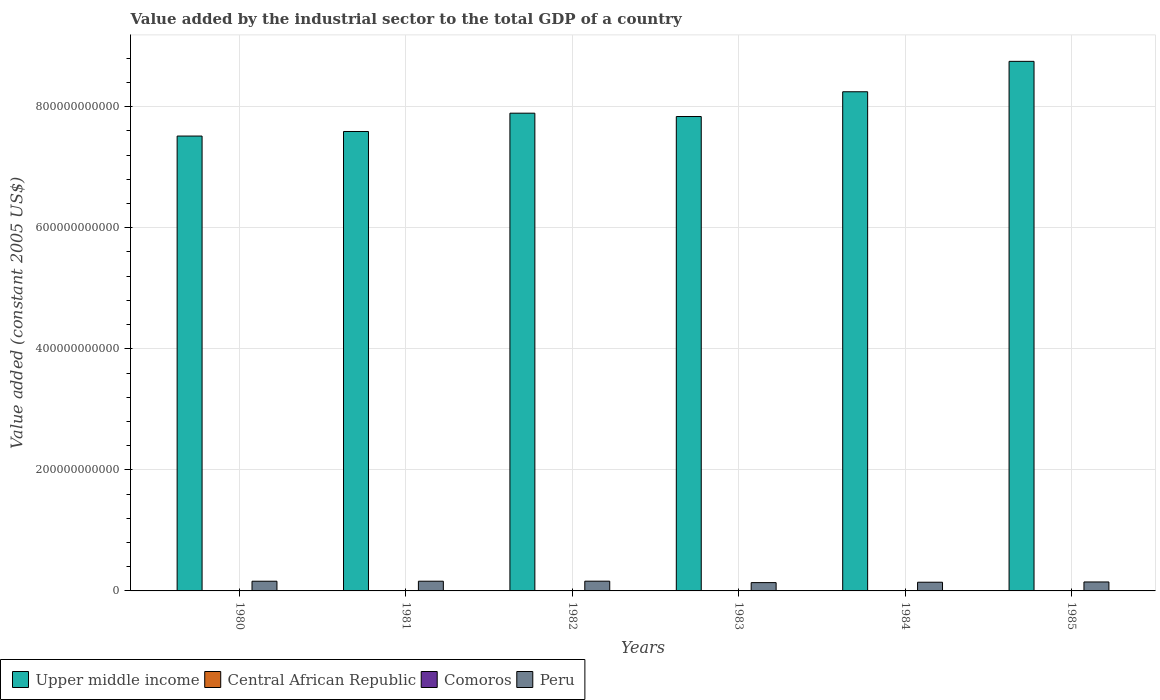How many groups of bars are there?
Your answer should be compact. 6. How many bars are there on the 4th tick from the right?
Your response must be concise. 4. What is the label of the 5th group of bars from the left?
Offer a terse response. 1984. What is the value added by the industrial sector in Peru in 1980?
Offer a terse response. 1.60e+1. Across all years, what is the maximum value added by the industrial sector in Peru?
Offer a very short reply. 1.61e+1. Across all years, what is the minimum value added by the industrial sector in Comoros?
Keep it short and to the point. 3.00e+07. In which year was the value added by the industrial sector in Peru minimum?
Provide a short and direct response. 1983. What is the total value added by the industrial sector in Peru in the graph?
Your answer should be compact. 9.11e+1. What is the difference between the value added by the industrial sector in Comoros in 1980 and that in 1982?
Give a very brief answer. -4.19e+06. What is the difference between the value added by the industrial sector in Comoros in 1982 and the value added by the industrial sector in Upper middle income in 1985?
Offer a very short reply. -8.75e+11. What is the average value added by the industrial sector in Comoros per year?
Your answer should be compact. 3.35e+07. In the year 1982, what is the difference between the value added by the industrial sector in Peru and value added by the industrial sector in Central African Republic?
Your response must be concise. 1.60e+1. In how many years, is the value added by the industrial sector in Central African Republic greater than 320000000000 US$?
Your answer should be compact. 0. What is the ratio of the value added by the industrial sector in Central African Republic in 1981 to that in 1983?
Offer a terse response. 0.92. Is the difference between the value added by the industrial sector in Peru in 1982 and 1985 greater than the difference between the value added by the industrial sector in Central African Republic in 1982 and 1985?
Your answer should be very brief. Yes. What is the difference between the highest and the second highest value added by the industrial sector in Peru?
Your answer should be very brief. 6.86e+07. What is the difference between the highest and the lowest value added by the industrial sector in Upper middle income?
Make the answer very short. 1.23e+11. What does the 1st bar from the left in 1984 represents?
Provide a succinct answer. Upper middle income. Is it the case that in every year, the sum of the value added by the industrial sector in Peru and value added by the industrial sector in Central African Republic is greater than the value added by the industrial sector in Upper middle income?
Give a very brief answer. No. How many bars are there?
Your answer should be compact. 24. How many years are there in the graph?
Ensure brevity in your answer.  6. What is the difference between two consecutive major ticks on the Y-axis?
Your answer should be very brief. 2.00e+11. Does the graph contain grids?
Your response must be concise. Yes. Where does the legend appear in the graph?
Make the answer very short. Bottom left. What is the title of the graph?
Give a very brief answer. Value added by the industrial sector to the total GDP of a country. Does "Italy" appear as one of the legend labels in the graph?
Give a very brief answer. No. What is the label or title of the Y-axis?
Offer a terse response. Value added (constant 2005 US$). What is the Value added (constant 2005 US$) of Upper middle income in 1980?
Offer a very short reply. 7.51e+11. What is the Value added (constant 2005 US$) of Central African Republic in 1980?
Offer a terse response. 1.59e+08. What is the Value added (constant 2005 US$) in Comoros in 1980?
Provide a succinct answer. 3.00e+07. What is the Value added (constant 2005 US$) in Peru in 1980?
Offer a terse response. 1.60e+1. What is the Value added (constant 2005 US$) of Upper middle income in 1981?
Offer a very short reply. 7.59e+11. What is the Value added (constant 2005 US$) in Central African Republic in 1981?
Give a very brief answer. 1.46e+08. What is the Value added (constant 2005 US$) in Comoros in 1981?
Your answer should be very brief. 3.03e+07. What is the Value added (constant 2005 US$) in Peru in 1981?
Keep it short and to the point. 1.60e+1. What is the Value added (constant 2005 US$) of Upper middle income in 1982?
Make the answer very short. 7.89e+11. What is the Value added (constant 2005 US$) of Central African Republic in 1982?
Keep it short and to the point. 1.46e+08. What is the Value added (constant 2005 US$) in Comoros in 1982?
Provide a short and direct response. 3.42e+07. What is the Value added (constant 2005 US$) of Peru in 1982?
Your answer should be compact. 1.61e+1. What is the Value added (constant 2005 US$) in Upper middle income in 1983?
Your response must be concise. 7.84e+11. What is the Value added (constant 2005 US$) in Central African Republic in 1983?
Keep it short and to the point. 1.59e+08. What is the Value added (constant 2005 US$) of Comoros in 1983?
Make the answer very short. 3.44e+07. What is the Value added (constant 2005 US$) of Peru in 1983?
Provide a succinct answer. 1.37e+1. What is the Value added (constant 2005 US$) in Upper middle income in 1984?
Provide a short and direct response. 8.25e+11. What is the Value added (constant 2005 US$) of Central African Republic in 1984?
Your response must be concise. 1.63e+08. What is the Value added (constant 2005 US$) in Comoros in 1984?
Your answer should be compact. 3.69e+07. What is the Value added (constant 2005 US$) in Peru in 1984?
Offer a very short reply. 1.44e+1. What is the Value added (constant 2005 US$) in Upper middle income in 1985?
Your response must be concise. 8.75e+11. What is the Value added (constant 2005 US$) of Central African Republic in 1985?
Ensure brevity in your answer.  1.69e+08. What is the Value added (constant 2005 US$) of Comoros in 1985?
Your answer should be compact. 3.53e+07. What is the Value added (constant 2005 US$) of Peru in 1985?
Offer a terse response. 1.48e+1. Across all years, what is the maximum Value added (constant 2005 US$) in Upper middle income?
Make the answer very short. 8.75e+11. Across all years, what is the maximum Value added (constant 2005 US$) of Central African Republic?
Ensure brevity in your answer.  1.69e+08. Across all years, what is the maximum Value added (constant 2005 US$) of Comoros?
Offer a terse response. 3.69e+07. Across all years, what is the maximum Value added (constant 2005 US$) in Peru?
Your answer should be very brief. 1.61e+1. Across all years, what is the minimum Value added (constant 2005 US$) of Upper middle income?
Your response must be concise. 7.51e+11. Across all years, what is the minimum Value added (constant 2005 US$) of Central African Republic?
Give a very brief answer. 1.46e+08. Across all years, what is the minimum Value added (constant 2005 US$) in Comoros?
Provide a succinct answer. 3.00e+07. Across all years, what is the minimum Value added (constant 2005 US$) in Peru?
Keep it short and to the point. 1.37e+1. What is the total Value added (constant 2005 US$) of Upper middle income in the graph?
Provide a short and direct response. 4.78e+12. What is the total Value added (constant 2005 US$) in Central African Republic in the graph?
Give a very brief answer. 9.42e+08. What is the total Value added (constant 2005 US$) of Comoros in the graph?
Provide a succinct answer. 2.01e+08. What is the total Value added (constant 2005 US$) of Peru in the graph?
Ensure brevity in your answer.  9.11e+1. What is the difference between the Value added (constant 2005 US$) in Upper middle income in 1980 and that in 1981?
Give a very brief answer. -7.55e+09. What is the difference between the Value added (constant 2005 US$) in Central African Republic in 1980 and that in 1981?
Your answer should be very brief. 1.27e+07. What is the difference between the Value added (constant 2005 US$) in Comoros in 1980 and that in 1981?
Make the answer very short. -2.66e+05. What is the difference between the Value added (constant 2005 US$) in Peru in 1980 and that in 1981?
Keep it short and to the point. -1.73e+07. What is the difference between the Value added (constant 2005 US$) in Upper middle income in 1980 and that in 1982?
Your answer should be very brief. -3.78e+1. What is the difference between the Value added (constant 2005 US$) in Central African Republic in 1980 and that in 1982?
Your answer should be compact. 1.34e+07. What is the difference between the Value added (constant 2005 US$) in Comoros in 1980 and that in 1982?
Offer a terse response. -4.19e+06. What is the difference between the Value added (constant 2005 US$) of Peru in 1980 and that in 1982?
Provide a short and direct response. -8.59e+07. What is the difference between the Value added (constant 2005 US$) of Upper middle income in 1980 and that in 1983?
Your response must be concise. -3.23e+1. What is the difference between the Value added (constant 2005 US$) of Comoros in 1980 and that in 1983?
Offer a very short reply. -4.40e+06. What is the difference between the Value added (constant 2005 US$) of Peru in 1980 and that in 1983?
Provide a succinct answer. 2.28e+09. What is the difference between the Value added (constant 2005 US$) of Upper middle income in 1980 and that in 1984?
Your answer should be very brief. -7.32e+1. What is the difference between the Value added (constant 2005 US$) in Central African Republic in 1980 and that in 1984?
Ensure brevity in your answer.  -4.45e+06. What is the difference between the Value added (constant 2005 US$) of Comoros in 1980 and that in 1984?
Give a very brief answer. -6.81e+06. What is the difference between the Value added (constant 2005 US$) of Peru in 1980 and that in 1984?
Your response must be concise. 1.64e+09. What is the difference between the Value added (constant 2005 US$) of Upper middle income in 1980 and that in 1985?
Offer a terse response. -1.23e+11. What is the difference between the Value added (constant 2005 US$) of Central African Republic in 1980 and that in 1985?
Ensure brevity in your answer.  -1.02e+07. What is the difference between the Value added (constant 2005 US$) of Comoros in 1980 and that in 1985?
Your response must be concise. -5.29e+06. What is the difference between the Value added (constant 2005 US$) in Peru in 1980 and that in 1985?
Make the answer very short. 1.20e+09. What is the difference between the Value added (constant 2005 US$) in Upper middle income in 1981 and that in 1982?
Offer a very short reply. -3.02e+1. What is the difference between the Value added (constant 2005 US$) in Central African Republic in 1981 and that in 1982?
Give a very brief answer. 6.36e+05. What is the difference between the Value added (constant 2005 US$) of Comoros in 1981 and that in 1982?
Give a very brief answer. -3.92e+06. What is the difference between the Value added (constant 2005 US$) in Peru in 1981 and that in 1982?
Keep it short and to the point. -6.86e+07. What is the difference between the Value added (constant 2005 US$) of Upper middle income in 1981 and that in 1983?
Keep it short and to the point. -2.47e+1. What is the difference between the Value added (constant 2005 US$) in Central African Republic in 1981 and that in 1983?
Keep it short and to the point. -1.27e+07. What is the difference between the Value added (constant 2005 US$) of Comoros in 1981 and that in 1983?
Offer a very short reply. -4.14e+06. What is the difference between the Value added (constant 2005 US$) of Peru in 1981 and that in 1983?
Keep it short and to the point. 2.30e+09. What is the difference between the Value added (constant 2005 US$) in Upper middle income in 1981 and that in 1984?
Ensure brevity in your answer.  -6.56e+1. What is the difference between the Value added (constant 2005 US$) in Central African Republic in 1981 and that in 1984?
Your response must be concise. -1.72e+07. What is the difference between the Value added (constant 2005 US$) of Comoros in 1981 and that in 1984?
Make the answer very short. -6.54e+06. What is the difference between the Value added (constant 2005 US$) of Peru in 1981 and that in 1984?
Your response must be concise. 1.66e+09. What is the difference between the Value added (constant 2005 US$) of Upper middle income in 1981 and that in 1985?
Ensure brevity in your answer.  -1.16e+11. What is the difference between the Value added (constant 2005 US$) of Central African Republic in 1981 and that in 1985?
Offer a very short reply. -2.29e+07. What is the difference between the Value added (constant 2005 US$) of Comoros in 1981 and that in 1985?
Your answer should be compact. -5.03e+06. What is the difference between the Value added (constant 2005 US$) of Peru in 1981 and that in 1985?
Give a very brief answer. 1.22e+09. What is the difference between the Value added (constant 2005 US$) of Upper middle income in 1982 and that in 1983?
Your answer should be compact. 5.53e+09. What is the difference between the Value added (constant 2005 US$) in Central African Republic in 1982 and that in 1983?
Keep it short and to the point. -1.34e+07. What is the difference between the Value added (constant 2005 US$) of Comoros in 1982 and that in 1983?
Keep it short and to the point. -2.15e+05. What is the difference between the Value added (constant 2005 US$) of Peru in 1982 and that in 1983?
Offer a terse response. 2.37e+09. What is the difference between the Value added (constant 2005 US$) of Upper middle income in 1982 and that in 1984?
Offer a very short reply. -3.54e+1. What is the difference between the Value added (constant 2005 US$) in Central African Republic in 1982 and that in 1984?
Provide a succinct answer. -1.78e+07. What is the difference between the Value added (constant 2005 US$) in Comoros in 1982 and that in 1984?
Ensure brevity in your answer.  -2.62e+06. What is the difference between the Value added (constant 2005 US$) of Peru in 1982 and that in 1984?
Provide a short and direct response. 1.73e+09. What is the difference between the Value added (constant 2005 US$) in Upper middle income in 1982 and that in 1985?
Offer a terse response. -8.56e+1. What is the difference between the Value added (constant 2005 US$) of Central African Republic in 1982 and that in 1985?
Provide a succinct answer. -2.35e+07. What is the difference between the Value added (constant 2005 US$) of Comoros in 1982 and that in 1985?
Offer a very short reply. -1.10e+06. What is the difference between the Value added (constant 2005 US$) of Peru in 1982 and that in 1985?
Your response must be concise. 1.28e+09. What is the difference between the Value added (constant 2005 US$) of Upper middle income in 1983 and that in 1984?
Your answer should be compact. -4.09e+1. What is the difference between the Value added (constant 2005 US$) of Central African Republic in 1983 and that in 1984?
Your answer should be very brief. -4.45e+06. What is the difference between the Value added (constant 2005 US$) of Comoros in 1983 and that in 1984?
Your answer should be very brief. -2.40e+06. What is the difference between the Value added (constant 2005 US$) of Peru in 1983 and that in 1984?
Give a very brief answer. -6.42e+08. What is the difference between the Value added (constant 2005 US$) of Upper middle income in 1983 and that in 1985?
Make the answer very short. -9.11e+1. What is the difference between the Value added (constant 2005 US$) of Central African Republic in 1983 and that in 1985?
Keep it short and to the point. -1.02e+07. What is the difference between the Value added (constant 2005 US$) in Comoros in 1983 and that in 1985?
Make the answer very short. -8.90e+05. What is the difference between the Value added (constant 2005 US$) of Peru in 1983 and that in 1985?
Your answer should be compact. -1.09e+09. What is the difference between the Value added (constant 2005 US$) in Upper middle income in 1984 and that in 1985?
Offer a terse response. -5.02e+1. What is the difference between the Value added (constant 2005 US$) in Central African Republic in 1984 and that in 1985?
Your answer should be compact. -5.72e+06. What is the difference between the Value added (constant 2005 US$) in Comoros in 1984 and that in 1985?
Your response must be concise. 1.51e+06. What is the difference between the Value added (constant 2005 US$) of Peru in 1984 and that in 1985?
Keep it short and to the point. -4.45e+08. What is the difference between the Value added (constant 2005 US$) of Upper middle income in 1980 and the Value added (constant 2005 US$) of Central African Republic in 1981?
Your answer should be compact. 7.51e+11. What is the difference between the Value added (constant 2005 US$) of Upper middle income in 1980 and the Value added (constant 2005 US$) of Comoros in 1981?
Provide a short and direct response. 7.51e+11. What is the difference between the Value added (constant 2005 US$) in Upper middle income in 1980 and the Value added (constant 2005 US$) in Peru in 1981?
Your answer should be compact. 7.35e+11. What is the difference between the Value added (constant 2005 US$) of Central African Republic in 1980 and the Value added (constant 2005 US$) of Comoros in 1981?
Your answer should be very brief. 1.29e+08. What is the difference between the Value added (constant 2005 US$) in Central African Republic in 1980 and the Value added (constant 2005 US$) in Peru in 1981?
Offer a terse response. -1.59e+1. What is the difference between the Value added (constant 2005 US$) of Comoros in 1980 and the Value added (constant 2005 US$) of Peru in 1981?
Provide a succinct answer. -1.60e+1. What is the difference between the Value added (constant 2005 US$) in Upper middle income in 1980 and the Value added (constant 2005 US$) in Central African Republic in 1982?
Offer a terse response. 7.51e+11. What is the difference between the Value added (constant 2005 US$) of Upper middle income in 1980 and the Value added (constant 2005 US$) of Comoros in 1982?
Provide a short and direct response. 7.51e+11. What is the difference between the Value added (constant 2005 US$) of Upper middle income in 1980 and the Value added (constant 2005 US$) of Peru in 1982?
Offer a terse response. 7.35e+11. What is the difference between the Value added (constant 2005 US$) of Central African Republic in 1980 and the Value added (constant 2005 US$) of Comoros in 1982?
Make the answer very short. 1.25e+08. What is the difference between the Value added (constant 2005 US$) of Central African Republic in 1980 and the Value added (constant 2005 US$) of Peru in 1982?
Your answer should be compact. -1.59e+1. What is the difference between the Value added (constant 2005 US$) in Comoros in 1980 and the Value added (constant 2005 US$) in Peru in 1982?
Ensure brevity in your answer.  -1.61e+1. What is the difference between the Value added (constant 2005 US$) of Upper middle income in 1980 and the Value added (constant 2005 US$) of Central African Republic in 1983?
Provide a succinct answer. 7.51e+11. What is the difference between the Value added (constant 2005 US$) of Upper middle income in 1980 and the Value added (constant 2005 US$) of Comoros in 1983?
Offer a terse response. 7.51e+11. What is the difference between the Value added (constant 2005 US$) in Upper middle income in 1980 and the Value added (constant 2005 US$) in Peru in 1983?
Keep it short and to the point. 7.38e+11. What is the difference between the Value added (constant 2005 US$) of Central African Republic in 1980 and the Value added (constant 2005 US$) of Comoros in 1983?
Provide a short and direct response. 1.24e+08. What is the difference between the Value added (constant 2005 US$) of Central African Republic in 1980 and the Value added (constant 2005 US$) of Peru in 1983?
Give a very brief answer. -1.36e+1. What is the difference between the Value added (constant 2005 US$) in Comoros in 1980 and the Value added (constant 2005 US$) in Peru in 1983?
Your response must be concise. -1.37e+1. What is the difference between the Value added (constant 2005 US$) in Upper middle income in 1980 and the Value added (constant 2005 US$) in Central African Republic in 1984?
Keep it short and to the point. 7.51e+11. What is the difference between the Value added (constant 2005 US$) in Upper middle income in 1980 and the Value added (constant 2005 US$) in Comoros in 1984?
Offer a very short reply. 7.51e+11. What is the difference between the Value added (constant 2005 US$) in Upper middle income in 1980 and the Value added (constant 2005 US$) in Peru in 1984?
Your response must be concise. 7.37e+11. What is the difference between the Value added (constant 2005 US$) of Central African Republic in 1980 and the Value added (constant 2005 US$) of Comoros in 1984?
Offer a very short reply. 1.22e+08. What is the difference between the Value added (constant 2005 US$) in Central African Republic in 1980 and the Value added (constant 2005 US$) in Peru in 1984?
Ensure brevity in your answer.  -1.42e+1. What is the difference between the Value added (constant 2005 US$) of Comoros in 1980 and the Value added (constant 2005 US$) of Peru in 1984?
Your response must be concise. -1.43e+1. What is the difference between the Value added (constant 2005 US$) of Upper middle income in 1980 and the Value added (constant 2005 US$) of Central African Republic in 1985?
Give a very brief answer. 7.51e+11. What is the difference between the Value added (constant 2005 US$) in Upper middle income in 1980 and the Value added (constant 2005 US$) in Comoros in 1985?
Give a very brief answer. 7.51e+11. What is the difference between the Value added (constant 2005 US$) in Upper middle income in 1980 and the Value added (constant 2005 US$) in Peru in 1985?
Your response must be concise. 7.37e+11. What is the difference between the Value added (constant 2005 US$) of Central African Republic in 1980 and the Value added (constant 2005 US$) of Comoros in 1985?
Make the answer very short. 1.24e+08. What is the difference between the Value added (constant 2005 US$) of Central African Republic in 1980 and the Value added (constant 2005 US$) of Peru in 1985?
Offer a terse response. -1.47e+1. What is the difference between the Value added (constant 2005 US$) in Comoros in 1980 and the Value added (constant 2005 US$) in Peru in 1985?
Offer a terse response. -1.48e+1. What is the difference between the Value added (constant 2005 US$) in Upper middle income in 1981 and the Value added (constant 2005 US$) in Central African Republic in 1982?
Ensure brevity in your answer.  7.59e+11. What is the difference between the Value added (constant 2005 US$) in Upper middle income in 1981 and the Value added (constant 2005 US$) in Comoros in 1982?
Your answer should be very brief. 7.59e+11. What is the difference between the Value added (constant 2005 US$) of Upper middle income in 1981 and the Value added (constant 2005 US$) of Peru in 1982?
Your answer should be very brief. 7.43e+11. What is the difference between the Value added (constant 2005 US$) of Central African Republic in 1981 and the Value added (constant 2005 US$) of Comoros in 1982?
Offer a terse response. 1.12e+08. What is the difference between the Value added (constant 2005 US$) of Central African Republic in 1981 and the Value added (constant 2005 US$) of Peru in 1982?
Give a very brief answer. -1.60e+1. What is the difference between the Value added (constant 2005 US$) of Comoros in 1981 and the Value added (constant 2005 US$) of Peru in 1982?
Make the answer very short. -1.61e+1. What is the difference between the Value added (constant 2005 US$) in Upper middle income in 1981 and the Value added (constant 2005 US$) in Central African Republic in 1983?
Provide a short and direct response. 7.59e+11. What is the difference between the Value added (constant 2005 US$) of Upper middle income in 1981 and the Value added (constant 2005 US$) of Comoros in 1983?
Provide a succinct answer. 7.59e+11. What is the difference between the Value added (constant 2005 US$) of Upper middle income in 1981 and the Value added (constant 2005 US$) of Peru in 1983?
Make the answer very short. 7.45e+11. What is the difference between the Value added (constant 2005 US$) of Central African Republic in 1981 and the Value added (constant 2005 US$) of Comoros in 1983?
Keep it short and to the point. 1.12e+08. What is the difference between the Value added (constant 2005 US$) of Central African Republic in 1981 and the Value added (constant 2005 US$) of Peru in 1983?
Give a very brief answer. -1.36e+1. What is the difference between the Value added (constant 2005 US$) in Comoros in 1981 and the Value added (constant 2005 US$) in Peru in 1983?
Offer a terse response. -1.37e+1. What is the difference between the Value added (constant 2005 US$) in Upper middle income in 1981 and the Value added (constant 2005 US$) in Central African Republic in 1984?
Ensure brevity in your answer.  7.59e+11. What is the difference between the Value added (constant 2005 US$) in Upper middle income in 1981 and the Value added (constant 2005 US$) in Comoros in 1984?
Offer a very short reply. 7.59e+11. What is the difference between the Value added (constant 2005 US$) of Upper middle income in 1981 and the Value added (constant 2005 US$) of Peru in 1984?
Keep it short and to the point. 7.45e+11. What is the difference between the Value added (constant 2005 US$) of Central African Republic in 1981 and the Value added (constant 2005 US$) of Comoros in 1984?
Offer a very short reply. 1.09e+08. What is the difference between the Value added (constant 2005 US$) in Central African Republic in 1981 and the Value added (constant 2005 US$) in Peru in 1984?
Keep it short and to the point. -1.42e+1. What is the difference between the Value added (constant 2005 US$) of Comoros in 1981 and the Value added (constant 2005 US$) of Peru in 1984?
Your response must be concise. -1.43e+1. What is the difference between the Value added (constant 2005 US$) in Upper middle income in 1981 and the Value added (constant 2005 US$) in Central African Republic in 1985?
Give a very brief answer. 7.59e+11. What is the difference between the Value added (constant 2005 US$) of Upper middle income in 1981 and the Value added (constant 2005 US$) of Comoros in 1985?
Provide a succinct answer. 7.59e+11. What is the difference between the Value added (constant 2005 US$) of Upper middle income in 1981 and the Value added (constant 2005 US$) of Peru in 1985?
Make the answer very short. 7.44e+11. What is the difference between the Value added (constant 2005 US$) in Central African Republic in 1981 and the Value added (constant 2005 US$) in Comoros in 1985?
Your answer should be very brief. 1.11e+08. What is the difference between the Value added (constant 2005 US$) of Central African Republic in 1981 and the Value added (constant 2005 US$) of Peru in 1985?
Offer a terse response. -1.47e+1. What is the difference between the Value added (constant 2005 US$) of Comoros in 1981 and the Value added (constant 2005 US$) of Peru in 1985?
Keep it short and to the point. -1.48e+1. What is the difference between the Value added (constant 2005 US$) in Upper middle income in 1982 and the Value added (constant 2005 US$) in Central African Republic in 1983?
Make the answer very short. 7.89e+11. What is the difference between the Value added (constant 2005 US$) of Upper middle income in 1982 and the Value added (constant 2005 US$) of Comoros in 1983?
Make the answer very short. 7.89e+11. What is the difference between the Value added (constant 2005 US$) in Upper middle income in 1982 and the Value added (constant 2005 US$) in Peru in 1983?
Give a very brief answer. 7.76e+11. What is the difference between the Value added (constant 2005 US$) of Central African Republic in 1982 and the Value added (constant 2005 US$) of Comoros in 1983?
Your answer should be compact. 1.11e+08. What is the difference between the Value added (constant 2005 US$) of Central African Republic in 1982 and the Value added (constant 2005 US$) of Peru in 1983?
Provide a short and direct response. -1.36e+1. What is the difference between the Value added (constant 2005 US$) in Comoros in 1982 and the Value added (constant 2005 US$) in Peru in 1983?
Give a very brief answer. -1.37e+1. What is the difference between the Value added (constant 2005 US$) of Upper middle income in 1982 and the Value added (constant 2005 US$) of Central African Republic in 1984?
Your answer should be compact. 7.89e+11. What is the difference between the Value added (constant 2005 US$) in Upper middle income in 1982 and the Value added (constant 2005 US$) in Comoros in 1984?
Keep it short and to the point. 7.89e+11. What is the difference between the Value added (constant 2005 US$) of Upper middle income in 1982 and the Value added (constant 2005 US$) of Peru in 1984?
Make the answer very short. 7.75e+11. What is the difference between the Value added (constant 2005 US$) in Central African Republic in 1982 and the Value added (constant 2005 US$) in Comoros in 1984?
Make the answer very short. 1.09e+08. What is the difference between the Value added (constant 2005 US$) in Central African Republic in 1982 and the Value added (constant 2005 US$) in Peru in 1984?
Ensure brevity in your answer.  -1.42e+1. What is the difference between the Value added (constant 2005 US$) of Comoros in 1982 and the Value added (constant 2005 US$) of Peru in 1984?
Ensure brevity in your answer.  -1.43e+1. What is the difference between the Value added (constant 2005 US$) of Upper middle income in 1982 and the Value added (constant 2005 US$) of Central African Republic in 1985?
Provide a succinct answer. 7.89e+11. What is the difference between the Value added (constant 2005 US$) of Upper middle income in 1982 and the Value added (constant 2005 US$) of Comoros in 1985?
Give a very brief answer. 7.89e+11. What is the difference between the Value added (constant 2005 US$) in Upper middle income in 1982 and the Value added (constant 2005 US$) in Peru in 1985?
Provide a succinct answer. 7.74e+11. What is the difference between the Value added (constant 2005 US$) in Central African Republic in 1982 and the Value added (constant 2005 US$) in Comoros in 1985?
Ensure brevity in your answer.  1.10e+08. What is the difference between the Value added (constant 2005 US$) of Central African Republic in 1982 and the Value added (constant 2005 US$) of Peru in 1985?
Offer a very short reply. -1.47e+1. What is the difference between the Value added (constant 2005 US$) in Comoros in 1982 and the Value added (constant 2005 US$) in Peru in 1985?
Make the answer very short. -1.48e+1. What is the difference between the Value added (constant 2005 US$) in Upper middle income in 1983 and the Value added (constant 2005 US$) in Central African Republic in 1984?
Provide a short and direct response. 7.84e+11. What is the difference between the Value added (constant 2005 US$) of Upper middle income in 1983 and the Value added (constant 2005 US$) of Comoros in 1984?
Your response must be concise. 7.84e+11. What is the difference between the Value added (constant 2005 US$) in Upper middle income in 1983 and the Value added (constant 2005 US$) in Peru in 1984?
Offer a very short reply. 7.69e+11. What is the difference between the Value added (constant 2005 US$) of Central African Republic in 1983 and the Value added (constant 2005 US$) of Comoros in 1984?
Offer a very short reply. 1.22e+08. What is the difference between the Value added (constant 2005 US$) of Central African Republic in 1983 and the Value added (constant 2005 US$) of Peru in 1984?
Provide a short and direct response. -1.42e+1. What is the difference between the Value added (constant 2005 US$) in Comoros in 1983 and the Value added (constant 2005 US$) in Peru in 1984?
Your answer should be compact. -1.43e+1. What is the difference between the Value added (constant 2005 US$) in Upper middle income in 1983 and the Value added (constant 2005 US$) in Central African Republic in 1985?
Your response must be concise. 7.84e+11. What is the difference between the Value added (constant 2005 US$) in Upper middle income in 1983 and the Value added (constant 2005 US$) in Comoros in 1985?
Keep it short and to the point. 7.84e+11. What is the difference between the Value added (constant 2005 US$) of Upper middle income in 1983 and the Value added (constant 2005 US$) of Peru in 1985?
Your answer should be compact. 7.69e+11. What is the difference between the Value added (constant 2005 US$) in Central African Republic in 1983 and the Value added (constant 2005 US$) in Comoros in 1985?
Keep it short and to the point. 1.24e+08. What is the difference between the Value added (constant 2005 US$) of Central African Republic in 1983 and the Value added (constant 2005 US$) of Peru in 1985?
Your answer should be very brief. -1.47e+1. What is the difference between the Value added (constant 2005 US$) of Comoros in 1983 and the Value added (constant 2005 US$) of Peru in 1985?
Offer a very short reply. -1.48e+1. What is the difference between the Value added (constant 2005 US$) in Upper middle income in 1984 and the Value added (constant 2005 US$) in Central African Republic in 1985?
Offer a very short reply. 8.24e+11. What is the difference between the Value added (constant 2005 US$) of Upper middle income in 1984 and the Value added (constant 2005 US$) of Comoros in 1985?
Provide a succinct answer. 8.25e+11. What is the difference between the Value added (constant 2005 US$) in Upper middle income in 1984 and the Value added (constant 2005 US$) in Peru in 1985?
Offer a very short reply. 8.10e+11. What is the difference between the Value added (constant 2005 US$) in Central African Republic in 1984 and the Value added (constant 2005 US$) in Comoros in 1985?
Give a very brief answer. 1.28e+08. What is the difference between the Value added (constant 2005 US$) of Central African Republic in 1984 and the Value added (constant 2005 US$) of Peru in 1985?
Your answer should be compact. -1.47e+1. What is the difference between the Value added (constant 2005 US$) of Comoros in 1984 and the Value added (constant 2005 US$) of Peru in 1985?
Keep it short and to the point. -1.48e+1. What is the average Value added (constant 2005 US$) of Upper middle income per year?
Your answer should be very brief. 7.97e+11. What is the average Value added (constant 2005 US$) of Central African Republic per year?
Offer a very short reply. 1.57e+08. What is the average Value added (constant 2005 US$) of Comoros per year?
Your answer should be compact. 3.35e+07. What is the average Value added (constant 2005 US$) of Peru per year?
Keep it short and to the point. 1.52e+1. In the year 1980, what is the difference between the Value added (constant 2005 US$) in Upper middle income and Value added (constant 2005 US$) in Central African Republic?
Your response must be concise. 7.51e+11. In the year 1980, what is the difference between the Value added (constant 2005 US$) of Upper middle income and Value added (constant 2005 US$) of Comoros?
Keep it short and to the point. 7.51e+11. In the year 1980, what is the difference between the Value added (constant 2005 US$) in Upper middle income and Value added (constant 2005 US$) in Peru?
Offer a terse response. 7.35e+11. In the year 1980, what is the difference between the Value added (constant 2005 US$) in Central African Republic and Value added (constant 2005 US$) in Comoros?
Give a very brief answer. 1.29e+08. In the year 1980, what is the difference between the Value added (constant 2005 US$) of Central African Republic and Value added (constant 2005 US$) of Peru?
Provide a succinct answer. -1.59e+1. In the year 1980, what is the difference between the Value added (constant 2005 US$) of Comoros and Value added (constant 2005 US$) of Peru?
Ensure brevity in your answer.  -1.60e+1. In the year 1981, what is the difference between the Value added (constant 2005 US$) of Upper middle income and Value added (constant 2005 US$) of Central African Republic?
Give a very brief answer. 7.59e+11. In the year 1981, what is the difference between the Value added (constant 2005 US$) in Upper middle income and Value added (constant 2005 US$) in Comoros?
Keep it short and to the point. 7.59e+11. In the year 1981, what is the difference between the Value added (constant 2005 US$) of Upper middle income and Value added (constant 2005 US$) of Peru?
Your answer should be compact. 7.43e+11. In the year 1981, what is the difference between the Value added (constant 2005 US$) of Central African Republic and Value added (constant 2005 US$) of Comoros?
Your answer should be compact. 1.16e+08. In the year 1981, what is the difference between the Value added (constant 2005 US$) of Central African Republic and Value added (constant 2005 US$) of Peru?
Your response must be concise. -1.59e+1. In the year 1981, what is the difference between the Value added (constant 2005 US$) of Comoros and Value added (constant 2005 US$) of Peru?
Offer a very short reply. -1.60e+1. In the year 1982, what is the difference between the Value added (constant 2005 US$) in Upper middle income and Value added (constant 2005 US$) in Central African Republic?
Your answer should be compact. 7.89e+11. In the year 1982, what is the difference between the Value added (constant 2005 US$) in Upper middle income and Value added (constant 2005 US$) in Comoros?
Provide a short and direct response. 7.89e+11. In the year 1982, what is the difference between the Value added (constant 2005 US$) in Upper middle income and Value added (constant 2005 US$) in Peru?
Provide a succinct answer. 7.73e+11. In the year 1982, what is the difference between the Value added (constant 2005 US$) of Central African Republic and Value added (constant 2005 US$) of Comoros?
Ensure brevity in your answer.  1.11e+08. In the year 1982, what is the difference between the Value added (constant 2005 US$) in Central African Republic and Value added (constant 2005 US$) in Peru?
Ensure brevity in your answer.  -1.60e+1. In the year 1982, what is the difference between the Value added (constant 2005 US$) in Comoros and Value added (constant 2005 US$) in Peru?
Your answer should be very brief. -1.61e+1. In the year 1983, what is the difference between the Value added (constant 2005 US$) in Upper middle income and Value added (constant 2005 US$) in Central African Republic?
Make the answer very short. 7.84e+11. In the year 1983, what is the difference between the Value added (constant 2005 US$) of Upper middle income and Value added (constant 2005 US$) of Comoros?
Provide a succinct answer. 7.84e+11. In the year 1983, what is the difference between the Value added (constant 2005 US$) in Upper middle income and Value added (constant 2005 US$) in Peru?
Your answer should be very brief. 7.70e+11. In the year 1983, what is the difference between the Value added (constant 2005 US$) of Central African Republic and Value added (constant 2005 US$) of Comoros?
Offer a terse response. 1.24e+08. In the year 1983, what is the difference between the Value added (constant 2005 US$) of Central African Republic and Value added (constant 2005 US$) of Peru?
Your answer should be very brief. -1.36e+1. In the year 1983, what is the difference between the Value added (constant 2005 US$) in Comoros and Value added (constant 2005 US$) in Peru?
Offer a very short reply. -1.37e+1. In the year 1984, what is the difference between the Value added (constant 2005 US$) of Upper middle income and Value added (constant 2005 US$) of Central African Republic?
Provide a short and direct response. 8.24e+11. In the year 1984, what is the difference between the Value added (constant 2005 US$) in Upper middle income and Value added (constant 2005 US$) in Comoros?
Provide a short and direct response. 8.25e+11. In the year 1984, what is the difference between the Value added (constant 2005 US$) of Upper middle income and Value added (constant 2005 US$) of Peru?
Give a very brief answer. 8.10e+11. In the year 1984, what is the difference between the Value added (constant 2005 US$) in Central African Republic and Value added (constant 2005 US$) in Comoros?
Your response must be concise. 1.27e+08. In the year 1984, what is the difference between the Value added (constant 2005 US$) in Central African Republic and Value added (constant 2005 US$) in Peru?
Your answer should be compact. -1.42e+1. In the year 1984, what is the difference between the Value added (constant 2005 US$) of Comoros and Value added (constant 2005 US$) of Peru?
Your answer should be very brief. -1.43e+1. In the year 1985, what is the difference between the Value added (constant 2005 US$) of Upper middle income and Value added (constant 2005 US$) of Central African Republic?
Offer a terse response. 8.75e+11. In the year 1985, what is the difference between the Value added (constant 2005 US$) of Upper middle income and Value added (constant 2005 US$) of Comoros?
Give a very brief answer. 8.75e+11. In the year 1985, what is the difference between the Value added (constant 2005 US$) in Upper middle income and Value added (constant 2005 US$) in Peru?
Offer a very short reply. 8.60e+11. In the year 1985, what is the difference between the Value added (constant 2005 US$) in Central African Republic and Value added (constant 2005 US$) in Comoros?
Keep it short and to the point. 1.34e+08. In the year 1985, what is the difference between the Value added (constant 2005 US$) of Central African Republic and Value added (constant 2005 US$) of Peru?
Offer a very short reply. -1.46e+1. In the year 1985, what is the difference between the Value added (constant 2005 US$) of Comoros and Value added (constant 2005 US$) of Peru?
Keep it short and to the point. -1.48e+1. What is the ratio of the Value added (constant 2005 US$) of Upper middle income in 1980 to that in 1981?
Offer a very short reply. 0.99. What is the ratio of the Value added (constant 2005 US$) of Central African Republic in 1980 to that in 1981?
Provide a succinct answer. 1.09. What is the ratio of the Value added (constant 2005 US$) in Comoros in 1980 to that in 1981?
Your answer should be compact. 0.99. What is the ratio of the Value added (constant 2005 US$) in Peru in 1980 to that in 1981?
Make the answer very short. 1. What is the ratio of the Value added (constant 2005 US$) in Upper middle income in 1980 to that in 1982?
Your answer should be compact. 0.95. What is the ratio of the Value added (constant 2005 US$) in Central African Republic in 1980 to that in 1982?
Your response must be concise. 1.09. What is the ratio of the Value added (constant 2005 US$) of Comoros in 1980 to that in 1982?
Provide a succinct answer. 0.88. What is the ratio of the Value added (constant 2005 US$) of Peru in 1980 to that in 1982?
Provide a succinct answer. 0.99. What is the ratio of the Value added (constant 2005 US$) of Upper middle income in 1980 to that in 1983?
Offer a very short reply. 0.96. What is the ratio of the Value added (constant 2005 US$) in Comoros in 1980 to that in 1983?
Your answer should be compact. 0.87. What is the ratio of the Value added (constant 2005 US$) in Peru in 1980 to that in 1983?
Keep it short and to the point. 1.17. What is the ratio of the Value added (constant 2005 US$) in Upper middle income in 1980 to that in 1984?
Your answer should be very brief. 0.91. What is the ratio of the Value added (constant 2005 US$) in Central African Republic in 1980 to that in 1984?
Keep it short and to the point. 0.97. What is the ratio of the Value added (constant 2005 US$) of Comoros in 1980 to that in 1984?
Give a very brief answer. 0.82. What is the ratio of the Value added (constant 2005 US$) in Peru in 1980 to that in 1984?
Your answer should be very brief. 1.11. What is the ratio of the Value added (constant 2005 US$) of Upper middle income in 1980 to that in 1985?
Give a very brief answer. 0.86. What is the ratio of the Value added (constant 2005 US$) of Central African Republic in 1980 to that in 1985?
Make the answer very short. 0.94. What is the ratio of the Value added (constant 2005 US$) of Comoros in 1980 to that in 1985?
Offer a very short reply. 0.85. What is the ratio of the Value added (constant 2005 US$) of Peru in 1980 to that in 1985?
Your answer should be compact. 1.08. What is the ratio of the Value added (constant 2005 US$) in Upper middle income in 1981 to that in 1982?
Your response must be concise. 0.96. What is the ratio of the Value added (constant 2005 US$) in Central African Republic in 1981 to that in 1982?
Keep it short and to the point. 1. What is the ratio of the Value added (constant 2005 US$) in Comoros in 1981 to that in 1982?
Provide a succinct answer. 0.89. What is the ratio of the Value added (constant 2005 US$) of Upper middle income in 1981 to that in 1983?
Ensure brevity in your answer.  0.97. What is the ratio of the Value added (constant 2005 US$) in Comoros in 1981 to that in 1983?
Give a very brief answer. 0.88. What is the ratio of the Value added (constant 2005 US$) in Peru in 1981 to that in 1983?
Your answer should be compact. 1.17. What is the ratio of the Value added (constant 2005 US$) of Upper middle income in 1981 to that in 1984?
Your response must be concise. 0.92. What is the ratio of the Value added (constant 2005 US$) in Central African Republic in 1981 to that in 1984?
Your answer should be compact. 0.89. What is the ratio of the Value added (constant 2005 US$) of Comoros in 1981 to that in 1984?
Offer a very short reply. 0.82. What is the ratio of the Value added (constant 2005 US$) of Peru in 1981 to that in 1984?
Your response must be concise. 1.12. What is the ratio of the Value added (constant 2005 US$) in Upper middle income in 1981 to that in 1985?
Provide a short and direct response. 0.87. What is the ratio of the Value added (constant 2005 US$) of Central African Republic in 1981 to that in 1985?
Offer a very short reply. 0.86. What is the ratio of the Value added (constant 2005 US$) of Comoros in 1981 to that in 1985?
Offer a terse response. 0.86. What is the ratio of the Value added (constant 2005 US$) of Peru in 1981 to that in 1985?
Offer a very short reply. 1.08. What is the ratio of the Value added (constant 2005 US$) of Upper middle income in 1982 to that in 1983?
Give a very brief answer. 1.01. What is the ratio of the Value added (constant 2005 US$) of Central African Republic in 1982 to that in 1983?
Offer a very short reply. 0.92. What is the ratio of the Value added (constant 2005 US$) in Comoros in 1982 to that in 1983?
Ensure brevity in your answer.  0.99. What is the ratio of the Value added (constant 2005 US$) of Peru in 1982 to that in 1983?
Keep it short and to the point. 1.17. What is the ratio of the Value added (constant 2005 US$) of Upper middle income in 1982 to that in 1984?
Your answer should be compact. 0.96. What is the ratio of the Value added (constant 2005 US$) of Central African Republic in 1982 to that in 1984?
Ensure brevity in your answer.  0.89. What is the ratio of the Value added (constant 2005 US$) in Comoros in 1982 to that in 1984?
Your answer should be compact. 0.93. What is the ratio of the Value added (constant 2005 US$) of Peru in 1982 to that in 1984?
Your answer should be very brief. 1.12. What is the ratio of the Value added (constant 2005 US$) in Upper middle income in 1982 to that in 1985?
Your response must be concise. 0.9. What is the ratio of the Value added (constant 2005 US$) of Central African Republic in 1982 to that in 1985?
Your response must be concise. 0.86. What is the ratio of the Value added (constant 2005 US$) of Comoros in 1982 to that in 1985?
Provide a succinct answer. 0.97. What is the ratio of the Value added (constant 2005 US$) in Peru in 1982 to that in 1985?
Your answer should be very brief. 1.09. What is the ratio of the Value added (constant 2005 US$) of Upper middle income in 1983 to that in 1984?
Offer a very short reply. 0.95. What is the ratio of the Value added (constant 2005 US$) of Central African Republic in 1983 to that in 1984?
Provide a succinct answer. 0.97. What is the ratio of the Value added (constant 2005 US$) in Comoros in 1983 to that in 1984?
Your answer should be compact. 0.93. What is the ratio of the Value added (constant 2005 US$) in Peru in 1983 to that in 1984?
Your answer should be very brief. 0.96. What is the ratio of the Value added (constant 2005 US$) in Upper middle income in 1983 to that in 1985?
Give a very brief answer. 0.9. What is the ratio of the Value added (constant 2005 US$) in Central African Republic in 1983 to that in 1985?
Offer a terse response. 0.94. What is the ratio of the Value added (constant 2005 US$) in Comoros in 1983 to that in 1985?
Your answer should be very brief. 0.97. What is the ratio of the Value added (constant 2005 US$) in Peru in 1983 to that in 1985?
Keep it short and to the point. 0.93. What is the ratio of the Value added (constant 2005 US$) in Upper middle income in 1984 to that in 1985?
Your answer should be compact. 0.94. What is the ratio of the Value added (constant 2005 US$) of Central African Republic in 1984 to that in 1985?
Your answer should be compact. 0.97. What is the ratio of the Value added (constant 2005 US$) in Comoros in 1984 to that in 1985?
Your response must be concise. 1.04. What is the ratio of the Value added (constant 2005 US$) of Peru in 1984 to that in 1985?
Offer a terse response. 0.97. What is the difference between the highest and the second highest Value added (constant 2005 US$) in Upper middle income?
Keep it short and to the point. 5.02e+1. What is the difference between the highest and the second highest Value added (constant 2005 US$) of Central African Republic?
Provide a short and direct response. 5.72e+06. What is the difference between the highest and the second highest Value added (constant 2005 US$) in Comoros?
Offer a very short reply. 1.51e+06. What is the difference between the highest and the second highest Value added (constant 2005 US$) of Peru?
Your answer should be very brief. 6.86e+07. What is the difference between the highest and the lowest Value added (constant 2005 US$) in Upper middle income?
Your response must be concise. 1.23e+11. What is the difference between the highest and the lowest Value added (constant 2005 US$) of Central African Republic?
Your answer should be very brief. 2.35e+07. What is the difference between the highest and the lowest Value added (constant 2005 US$) in Comoros?
Offer a very short reply. 6.81e+06. What is the difference between the highest and the lowest Value added (constant 2005 US$) in Peru?
Provide a short and direct response. 2.37e+09. 